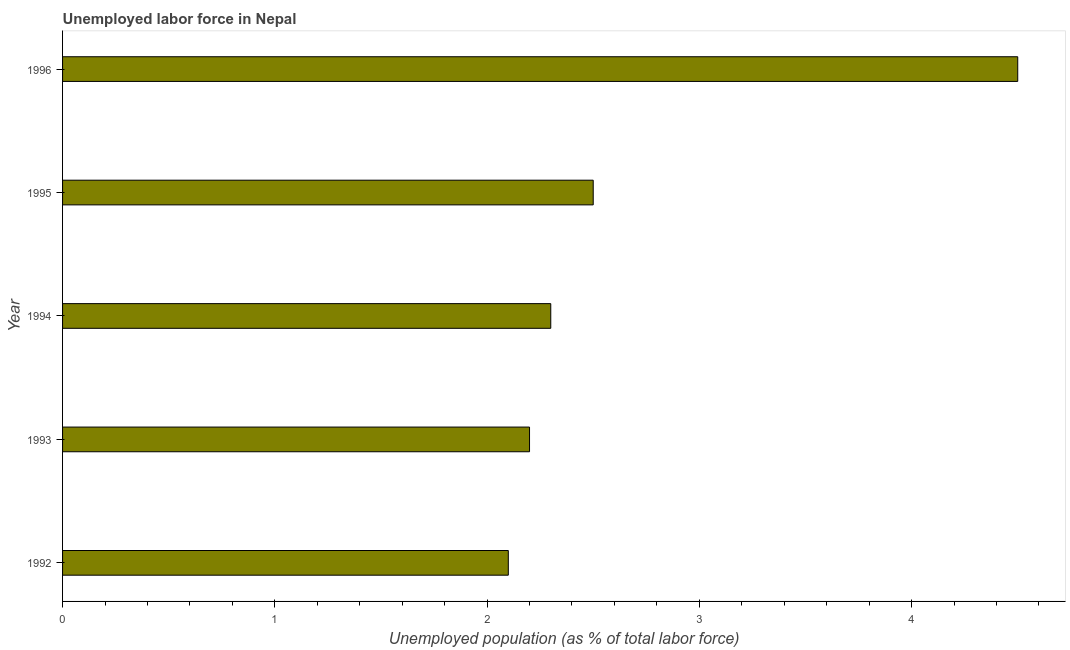Does the graph contain any zero values?
Offer a very short reply. No. What is the title of the graph?
Provide a short and direct response. Unemployed labor force in Nepal. What is the label or title of the X-axis?
Keep it short and to the point. Unemployed population (as % of total labor force). What is the total unemployed population in 1992?
Provide a short and direct response. 2.1. Across all years, what is the minimum total unemployed population?
Ensure brevity in your answer.  2.1. In which year was the total unemployed population minimum?
Offer a very short reply. 1992. What is the sum of the total unemployed population?
Your response must be concise. 13.6. What is the difference between the total unemployed population in 1993 and 1996?
Keep it short and to the point. -2.3. What is the average total unemployed population per year?
Your answer should be very brief. 2.72. What is the median total unemployed population?
Keep it short and to the point. 2.3. Do a majority of the years between 1995 and 1996 (inclusive) have total unemployed population greater than 1.2 %?
Give a very brief answer. Yes. What is the ratio of the total unemployed population in 1993 to that in 1996?
Ensure brevity in your answer.  0.49. What is the difference between the highest and the second highest total unemployed population?
Your answer should be compact. 2. What is the difference between the highest and the lowest total unemployed population?
Offer a terse response. 2.4. In how many years, is the total unemployed population greater than the average total unemployed population taken over all years?
Keep it short and to the point. 1. Are all the bars in the graph horizontal?
Offer a terse response. Yes. How many years are there in the graph?
Make the answer very short. 5. Are the values on the major ticks of X-axis written in scientific E-notation?
Offer a very short reply. No. What is the Unemployed population (as % of total labor force) of 1992?
Offer a very short reply. 2.1. What is the Unemployed population (as % of total labor force) in 1993?
Keep it short and to the point. 2.2. What is the Unemployed population (as % of total labor force) in 1994?
Give a very brief answer. 2.3. What is the Unemployed population (as % of total labor force) of 1995?
Your answer should be very brief. 2.5. What is the Unemployed population (as % of total labor force) of 1996?
Provide a short and direct response. 4.5. What is the difference between the Unemployed population (as % of total labor force) in 1992 and 1993?
Provide a succinct answer. -0.1. What is the difference between the Unemployed population (as % of total labor force) in 1992 and 1994?
Your answer should be very brief. -0.2. What is the difference between the Unemployed population (as % of total labor force) in 1992 and 1996?
Provide a succinct answer. -2.4. What is the difference between the Unemployed population (as % of total labor force) in 1993 and 1994?
Provide a succinct answer. -0.1. What is the difference between the Unemployed population (as % of total labor force) in 1993 and 1996?
Offer a terse response. -2.3. What is the difference between the Unemployed population (as % of total labor force) in 1994 and 1995?
Ensure brevity in your answer.  -0.2. What is the ratio of the Unemployed population (as % of total labor force) in 1992 to that in 1993?
Ensure brevity in your answer.  0.95. What is the ratio of the Unemployed population (as % of total labor force) in 1992 to that in 1994?
Provide a short and direct response. 0.91. What is the ratio of the Unemployed population (as % of total labor force) in 1992 to that in 1995?
Give a very brief answer. 0.84. What is the ratio of the Unemployed population (as % of total labor force) in 1992 to that in 1996?
Offer a terse response. 0.47. What is the ratio of the Unemployed population (as % of total labor force) in 1993 to that in 1995?
Your response must be concise. 0.88. What is the ratio of the Unemployed population (as % of total labor force) in 1993 to that in 1996?
Keep it short and to the point. 0.49. What is the ratio of the Unemployed population (as % of total labor force) in 1994 to that in 1995?
Give a very brief answer. 0.92. What is the ratio of the Unemployed population (as % of total labor force) in 1994 to that in 1996?
Your answer should be very brief. 0.51. What is the ratio of the Unemployed population (as % of total labor force) in 1995 to that in 1996?
Offer a very short reply. 0.56. 